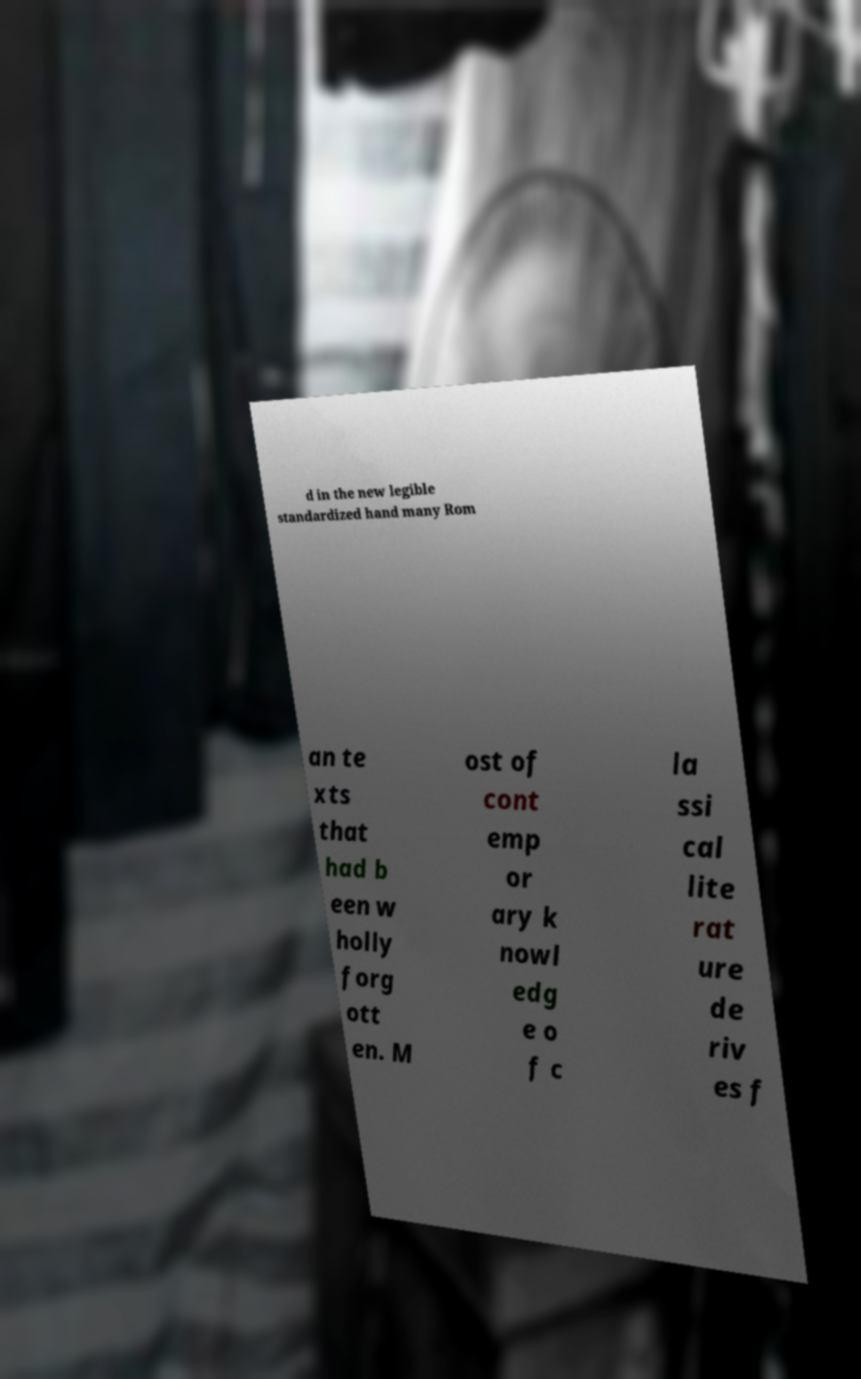Could you extract and type out the text from this image? d in the new legible standardized hand many Rom an te xts that had b een w holly forg ott en. M ost of cont emp or ary k nowl edg e o f c la ssi cal lite rat ure de riv es f 